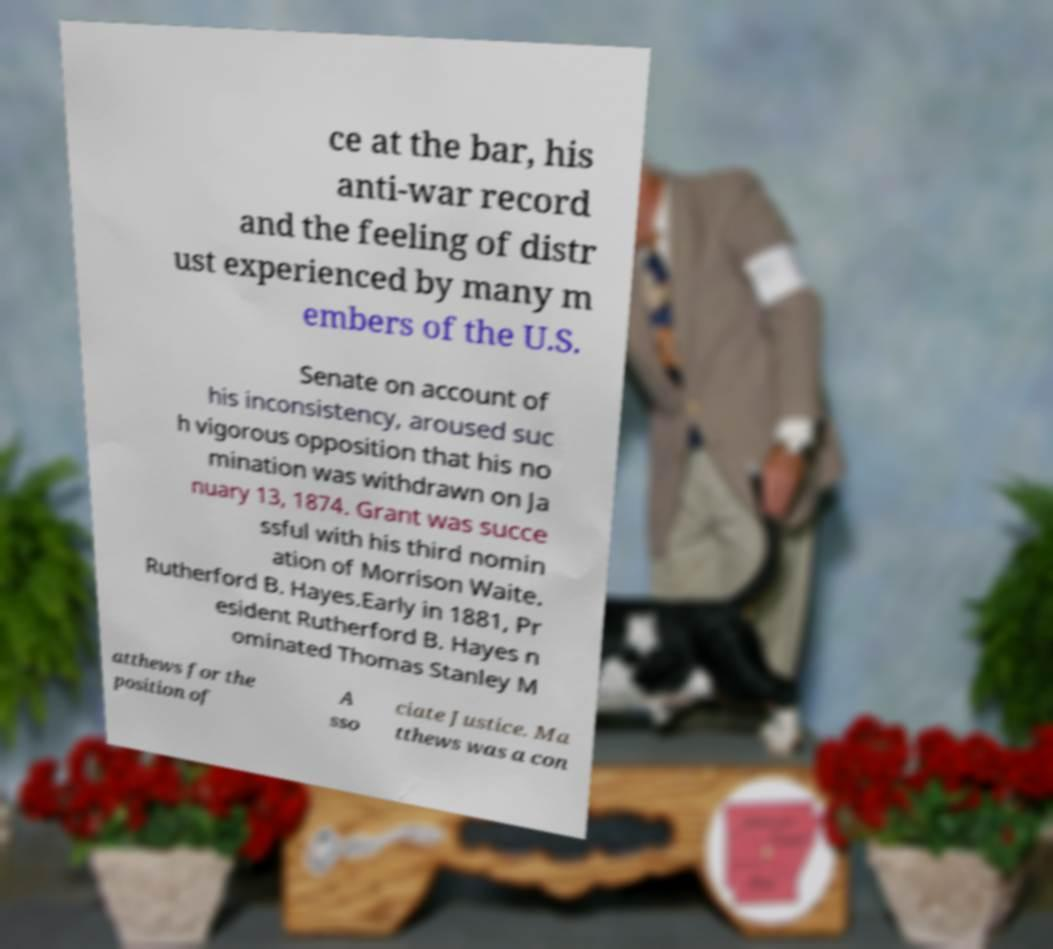Could you extract and type out the text from this image? ce at the bar, his anti-war record and the feeling of distr ust experienced by many m embers of the U.S. Senate on account of his inconsistency, aroused suc h vigorous opposition that his no mination was withdrawn on Ja nuary 13, 1874. Grant was succe ssful with his third nomin ation of Morrison Waite. Rutherford B. Hayes.Early in 1881, Pr esident Rutherford B. Hayes n ominated Thomas Stanley M atthews for the position of A sso ciate Justice. Ma tthews was a con 